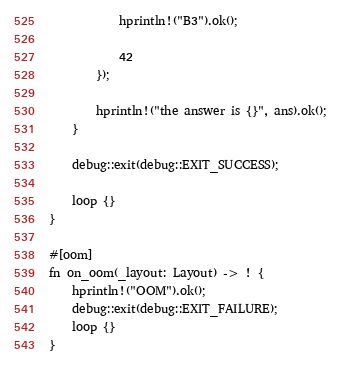Convert code to text. <code><loc_0><loc_0><loc_500><loc_500><_Rust_>
            hprintln!("B3").ok();

            42
        });

        hprintln!("the answer is {}", ans).ok();
    }

    debug::exit(debug::EXIT_SUCCESS);

    loop {}
}

#[oom]
fn on_oom(_layout: Layout) -> ! {
    hprintln!("OOM").ok();
    debug::exit(debug::EXIT_FAILURE);
    loop {}
}
</code> 